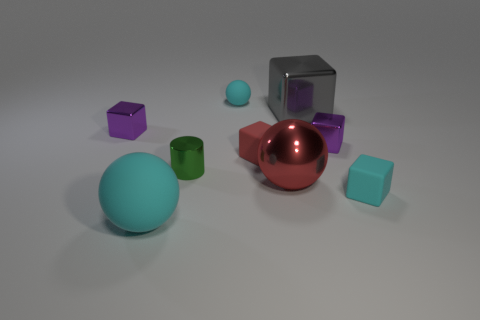There is a tiny red rubber object; how many red metal spheres are behind it?
Offer a very short reply. 0. What shape is the green object that is behind the matte object that is to the left of the green metal thing?
Give a very brief answer. Cylinder. What shape is the red thing that is made of the same material as the gray block?
Ensure brevity in your answer.  Sphere. There is a purple metallic cube on the left side of the small ball; does it have the same size as the red object behind the big red sphere?
Keep it short and to the point. Yes. There is a tiny cyan object that is behind the big gray object; what is its shape?
Give a very brief answer. Sphere. The small matte ball has what color?
Make the answer very short. Cyan. There is a gray shiny block; does it have the same size as the cyan thing behind the green metal cylinder?
Offer a very short reply. No. How many metal things are small cylinders or yellow things?
Keep it short and to the point. 1. Is there anything else that is the same material as the tiny sphere?
Provide a short and direct response. Yes. Do the big block and the rubber sphere that is right of the small cylinder have the same color?
Offer a terse response. No. 